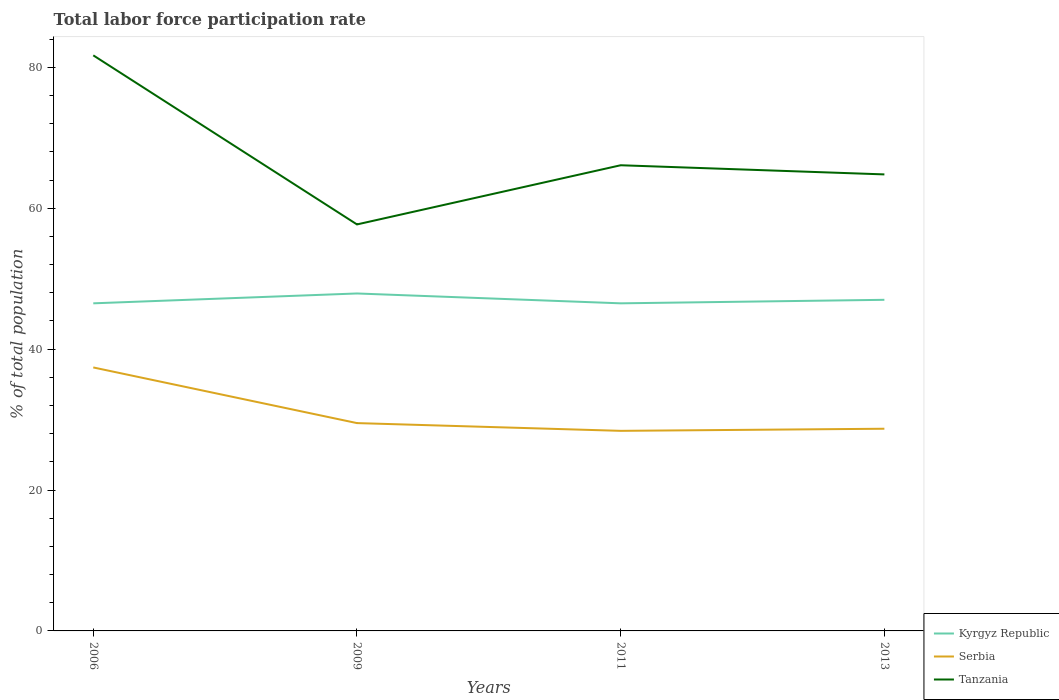Does the line corresponding to Tanzania intersect with the line corresponding to Serbia?
Keep it short and to the point. No. Across all years, what is the maximum total labor force participation rate in Serbia?
Keep it short and to the point. 28.4. What is the total total labor force participation rate in Tanzania in the graph?
Offer a very short reply. 16.9. What is the difference between the highest and the second highest total labor force participation rate in Serbia?
Offer a very short reply. 9. What is the difference between the highest and the lowest total labor force participation rate in Serbia?
Provide a succinct answer. 1. Is the total labor force participation rate in Kyrgyz Republic strictly greater than the total labor force participation rate in Serbia over the years?
Your answer should be very brief. No. How many years are there in the graph?
Keep it short and to the point. 4. What is the difference between two consecutive major ticks on the Y-axis?
Offer a very short reply. 20. Does the graph contain grids?
Provide a succinct answer. No. How many legend labels are there?
Keep it short and to the point. 3. What is the title of the graph?
Offer a terse response. Total labor force participation rate. Does "Andorra" appear as one of the legend labels in the graph?
Ensure brevity in your answer.  No. What is the label or title of the Y-axis?
Provide a succinct answer. % of total population. What is the % of total population of Kyrgyz Republic in 2006?
Your answer should be compact. 46.5. What is the % of total population in Serbia in 2006?
Your answer should be very brief. 37.4. What is the % of total population of Tanzania in 2006?
Offer a terse response. 81.7. What is the % of total population of Kyrgyz Republic in 2009?
Provide a short and direct response. 47.9. What is the % of total population of Serbia in 2009?
Give a very brief answer. 29.5. What is the % of total population of Tanzania in 2009?
Ensure brevity in your answer.  57.7. What is the % of total population of Kyrgyz Republic in 2011?
Provide a succinct answer. 46.5. What is the % of total population in Serbia in 2011?
Give a very brief answer. 28.4. What is the % of total population of Tanzania in 2011?
Provide a succinct answer. 66.1. What is the % of total population in Serbia in 2013?
Your answer should be very brief. 28.7. What is the % of total population of Tanzania in 2013?
Your response must be concise. 64.8. Across all years, what is the maximum % of total population in Kyrgyz Republic?
Ensure brevity in your answer.  47.9. Across all years, what is the maximum % of total population of Serbia?
Your answer should be very brief. 37.4. Across all years, what is the maximum % of total population of Tanzania?
Offer a very short reply. 81.7. Across all years, what is the minimum % of total population in Kyrgyz Republic?
Keep it short and to the point. 46.5. Across all years, what is the minimum % of total population of Serbia?
Your response must be concise. 28.4. Across all years, what is the minimum % of total population in Tanzania?
Your answer should be very brief. 57.7. What is the total % of total population of Kyrgyz Republic in the graph?
Offer a terse response. 187.9. What is the total % of total population of Serbia in the graph?
Make the answer very short. 124. What is the total % of total population of Tanzania in the graph?
Provide a short and direct response. 270.3. What is the difference between the % of total population in Kyrgyz Republic in 2006 and that in 2009?
Your answer should be very brief. -1.4. What is the difference between the % of total population in Tanzania in 2006 and that in 2009?
Your answer should be compact. 24. What is the difference between the % of total population of Kyrgyz Republic in 2006 and that in 2011?
Your response must be concise. 0. What is the difference between the % of total population in Tanzania in 2006 and that in 2011?
Provide a short and direct response. 15.6. What is the difference between the % of total population in Kyrgyz Republic in 2006 and that in 2013?
Your response must be concise. -0.5. What is the difference between the % of total population of Serbia in 2006 and that in 2013?
Offer a very short reply. 8.7. What is the difference between the % of total population of Kyrgyz Republic in 2009 and that in 2011?
Give a very brief answer. 1.4. What is the difference between the % of total population in Tanzania in 2009 and that in 2011?
Offer a very short reply. -8.4. What is the difference between the % of total population of Serbia in 2009 and that in 2013?
Give a very brief answer. 0.8. What is the difference between the % of total population in Tanzania in 2009 and that in 2013?
Your answer should be compact. -7.1. What is the difference between the % of total population of Kyrgyz Republic in 2011 and that in 2013?
Offer a terse response. -0.5. What is the difference between the % of total population of Tanzania in 2011 and that in 2013?
Your response must be concise. 1.3. What is the difference between the % of total population in Serbia in 2006 and the % of total population in Tanzania in 2009?
Provide a succinct answer. -20.3. What is the difference between the % of total population in Kyrgyz Republic in 2006 and the % of total population in Serbia in 2011?
Keep it short and to the point. 18.1. What is the difference between the % of total population in Kyrgyz Republic in 2006 and the % of total population in Tanzania in 2011?
Make the answer very short. -19.6. What is the difference between the % of total population in Serbia in 2006 and the % of total population in Tanzania in 2011?
Offer a terse response. -28.7. What is the difference between the % of total population of Kyrgyz Republic in 2006 and the % of total population of Tanzania in 2013?
Your response must be concise. -18.3. What is the difference between the % of total population in Serbia in 2006 and the % of total population in Tanzania in 2013?
Your answer should be very brief. -27.4. What is the difference between the % of total population of Kyrgyz Republic in 2009 and the % of total population of Tanzania in 2011?
Offer a terse response. -18.2. What is the difference between the % of total population in Serbia in 2009 and the % of total population in Tanzania in 2011?
Provide a short and direct response. -36.6. What is the difference between the % of total population of Kyrgyz Republic in 2009 and the % of total population of Serbia in 2013?
Provide a short and direct response. 19.2. What is the difference between the % of total population in Kyrgyz Republic in 2009 and the % of total population in Tanzania in 2013?
Keep it short and to the point. -16.9. What is the difference between the % of total population in Serbia in 2009 and the % of total population in Tanzania in 2013?
Offer a terse response. -35.3. What is the difference between the % of total population of Kyrgyz Republic in 2011 and the % of total population of Serbia in 2013?
Offer a terse response. 17.8. What is the difference between the % of total population in Kyrgyz Republic in 2011 and the % of total population in Tanzania in 2013?
Give a very brief answer. -18.3. What is the difference between the % of total population in Serbia in 2011 and the % of total population in Tanzania in 2013?
Your answer should be compact. -36.4. What is the average % of total population in Kyrgyz Republic per year?
Make the answer very short. 46.98. What is the average % of total population in Serbia per year?
Make the answer very short. 31. What is the average % of total population of Tanzania per year?
Your answer should be compact. 67.58. In the year 2006, what is the difference between the % of total population of Kyrgyz Republic and % of total population of Tanzania?
Offer a very short reply. -35.2. In the year 2006, what is the difference between the % of total population in Serbia and % of total population in Tanzania?
Ensure brevity in your answer.  -44.3. In the year 2009, what is the difference between the % of total population in Kyrgyz Republic and % of total population in Tanzania?
Your answer should be compact. -9.8. In the year 2009, what is the difference between the % of total population in Serbia and % of total population in Tanzania?
Make the answer very short. -28.2. In the year 2011, what is the difference between the % of total population of Kyrgyz Republic and % of total population of Serbia?
Keep it short and to the point. 18.1. In the year 2011, what is the difference between the % of total population in Kyrgyz Republic and % of total population in Tanzania?
Offer a terse response. -19.6. In the year 2011, what is the difference between the % of total population of Serbia and % of total population of Tanzania?
Your response must be concise. -37.7. In the year 2013, what is the difference between the % of total population of Kyrgyz Republic and % of total population of Tanzania?
Provide a short and direct response. -17.8. In the year 2013, what is the difference between the % of total population of Serbia and % of total population of Tanzania?
Keep it short and to the point. -36.1. What is the ratio of the % of total population in Kyrgyz Republic in 2006 to that in 2009?
Provide a short and direct response. 0.97. What is the ratio of the % of total population in Serbia in 2006 to that in 2009?
Make the answer very short. 1.27. What is the ratio of the % of total population of Tanzania in 2006 to that in 2009?
Make the answer very short. 1.42. What is the ratio of the % of total population in Serbia in 2006 to that in 2011?
Give a very brief answer. 1.32. What is the ratio of the % of total population in Tanzania in 2006 to that in 2011?
Keep it short and to the point. 1.24. What is the ratio of the % of total population in Serbia in 2006 to that in 2013?
Your answer should be very brief. 1.3. What is the ratio of the % of total population in Tanzania in 2006 to that in 2013?
Your answer should be very brief. 1.26. What is the ratio of the % of total population of Kyrgyz Republic in 2009 to that in 2011?
Make the answer very short. 1.03. What is the ratio of the % of total population in Serbia in 2009 to that in 2011?
Offer a very short reply. 1.04. What is the ratio of the % of total population of Tanzania in 2009 to that in 2011?
Provide a succinct answer. 0.87. What is the ratio of the % of total population of Kyrgyz Republic in 2009 to that in 2013?
Your response must be concise. 1.02. What is the ratio of the % of total population in Serbia in 2009 to that in 2013?
Your answer should be compact. 1.03. What is the ratio of the % of total population of Tanzania in 2009 to that in 2013?
Give a very brief answer. 0.89. What is the ratio of the % of total population of Kyrgyz Republic in 2011 to that in 2013?
Give a very brief answer. 0.99. What is the ratio of the % of total population of Tanzania in 2011 to that in 2013?
Your answer should be very brief. 1.02. What is the difference between the highest and the second highest % of total population in Kyrgyz Republic?
Provide a short and direct response. 0.9. What is the difference between the highest and the second highest % of total population of Tanzania?
Make the answer very short. 15.6. What is the difference between the highest and the lowest % of total population in Kyrgyz Republic?
Your response must be concise. 1.4. What is the difference between the highest and the lowest % of total population of Serbia?
Your answer should be very brief. 9. 